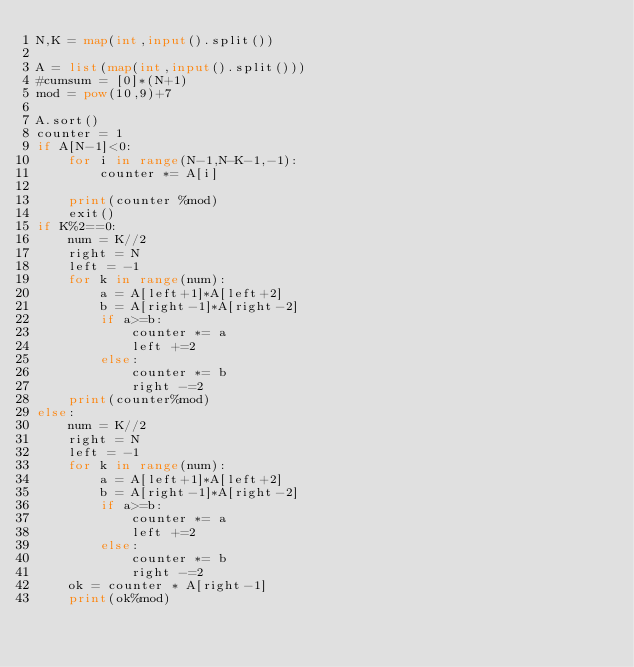<code> <loc_0><loc_0><loc_500><loc_500><_Python_>N,K = map(int,input().split())

A = list(map(int,input().split()))
#cumsum = [0]*(N+1)
mod = pow(10,9)+7

A.sort()
counter = 1
if A[N-1]<0:
    for i in range(N-1,N-K-1,-1):
        counter *= A[i]
    
    print(counter %mod)
    exit()
if K%2==0:
    num = K//2
    right = N
    left = -1
    for k in range(num):
        a = A[left+1]*A[left+2]
        b = A[right-1]*A[right-2]
        if a>=b:
            counter *= a
            left +=2
        else:
            counter *= b
            right -=2
    print(counter%mod)
else:
    num = K//2
    right = N
    left = -1
    for k in range(num):
        a = A[left+1]*A[left+2]
        b = A[right-1]*A[right-2]
        if a>=b:
            counter *= a
            left +=2
        else:
            counter *= b
            right -=2
    ok = counter * A[right-1]
    print(ok%mod)</code> 